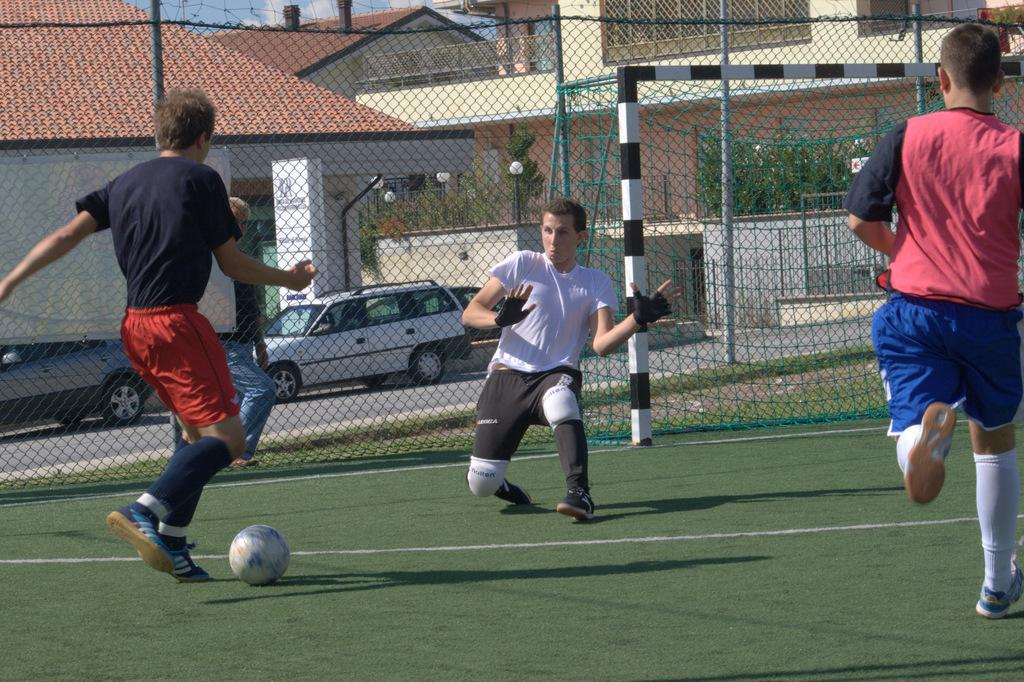What sport are the three players engaged in within the image? The three players are playing football in the image. What type of barrier can be seen in the image? There is a metal fence in the image. What structures are visible in the background of the image? Houses are visible in the background of the image. What vehicles can be seen on the road in the image? There are parked cars on the road in the image. What type of jewel is being used as a football in the image? There is no jewel being used as a football in the image; the players are using a regular football. Can you see any yaks in the image? There are no yaks present in the image. 